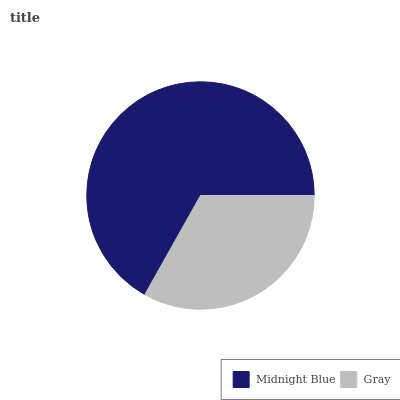Is Gray the minimum?
Answer yes or no. Yes. Is Midnight Blue the maximum?
Answer yes or no. Yes. Is Gray the maximum?
Answer yes or no. No. Is Midnight Blue greater than Gray?
Answer yes or no. Yes. Is Gray less than Midnight Blue?
Answer yes or no. Yes. Is Gray greater than Midnight Blue?
Answer yes or no. No. Is Midnight Blue less than Gray?
Answer yes or no. No. Is Midnight Blue the high median?
Answer yes or no. Yes. Is Gray the low median?
Answer yes or no. Yes. Is Gray the high median?
Answer yes or no. No. Is Midnight Blue the low median?
Answer yes or no. No. 